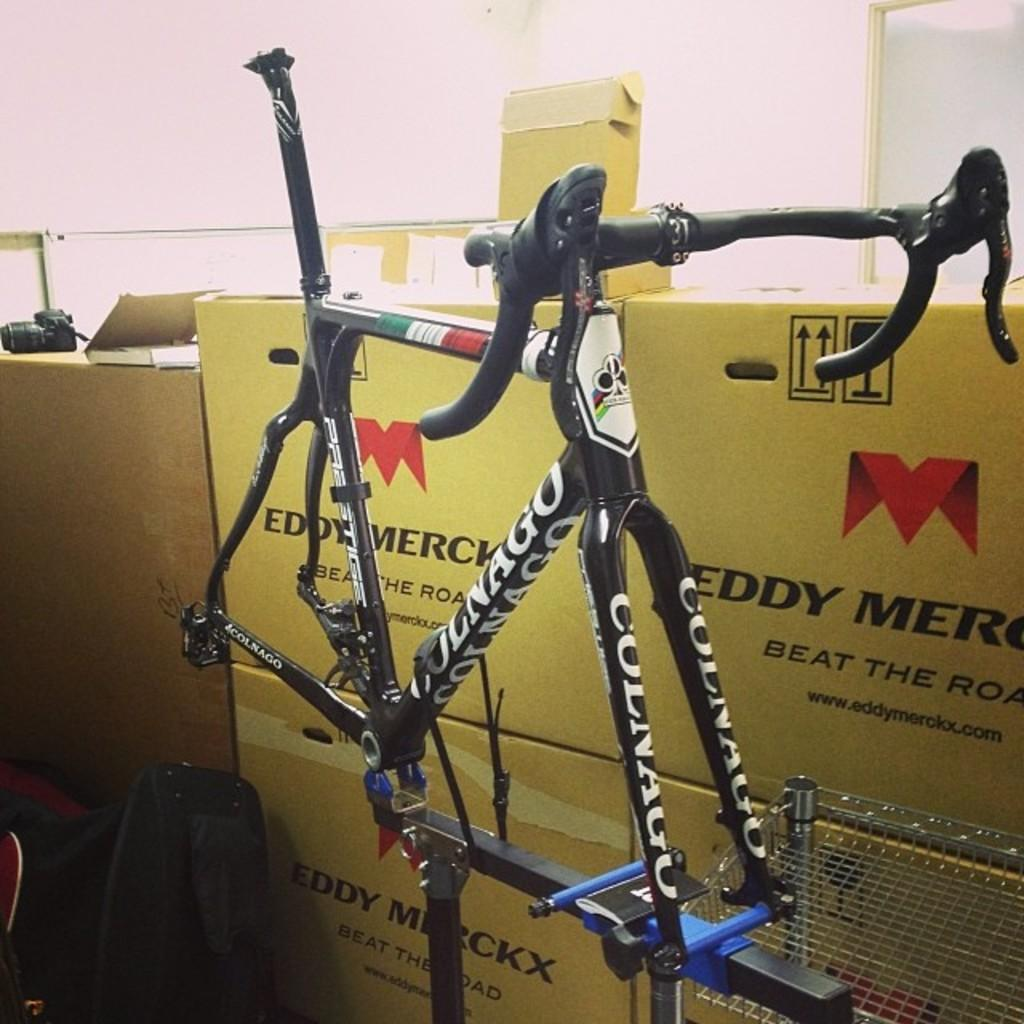What is the main object in the image? There is a bicycle in the image. How much of the bicycle can be seen? The bicycle is partially visible, showing its body. What else is present in the image besides the bicycle? There are cardboard boxes on the right side of the image. What can be seen in the background of the image? There is a wall in the background of the image. Can you see the ocean in the background of the image? No, there is no ocean visible in the image; it features a wall in the background. 